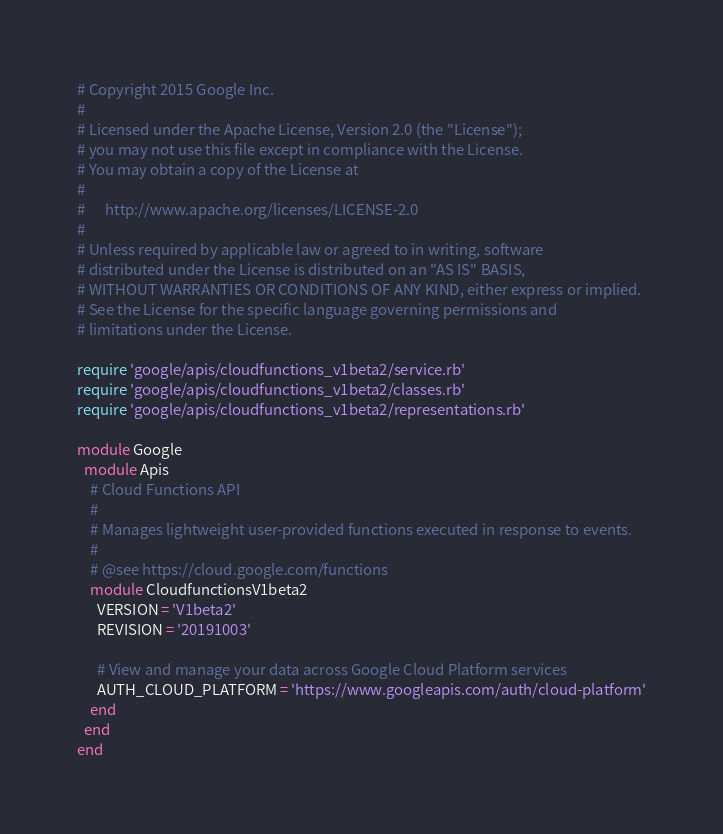<code> <loc_0><loc_0><loc_500><loc_500><_Ruby_># Copyright 2015 Google Inc.
#
# Licensed under the Apache License, Version 2.0 (the "License");
# you may not use this file except in compliance with the License.
# You may obtain a copy of the License at
#
#      http://www.apache.org/licenses/LICENSE-2.0
#
# Unless required by applicable law or agreed to in writing, software
# distributed under the License is distributed on an "AS IS" BASIS,
# WITHOUT WARRANTIES OR CONDITIONS OF ANY KIND, either express or implied.
# See the License for the specific language governing permissions and
# limitations under the License.

require 'google/apis/cloudfunctions_v1beta2/service.rb'
require 'google/apis/cloudfunctions_v1beta2/classes.rb'
require 'google/apis/cloudfunctions_v1beta2/representations.rb'

module Google
  module Apis
    # Cloud Functions API
    #
    # Manages lightweight user-provided functions executed in response to events.
    #
    # @see https://cloud.google.com/functions
    module CloudfunctionsV1beta2
      VERSION = 'V1beta2'
      REVISION = '20191003'

      # View and manage your data across Google Cloud Platform services
      AUTH_CLOUD_PLATFORM = 'https://www.googleapis.com/auth/cloud-platform'
    end
  end
end
</code> 